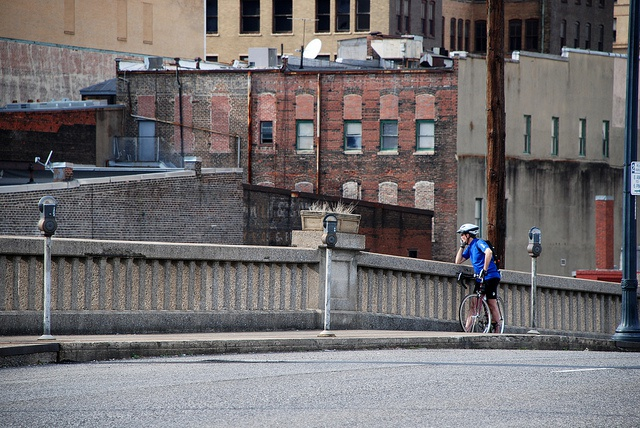Describe the objects in this image and their specific colors. I can see bicycle in gray, black, and darkgray tones, people in gray, black, darkblue, and navy tones, parking meter in gray, black, and darkgray tones, parking meter in gray, black, darkgray, and navy tones, and parking meter in gray, black, and blue tones in this image. 